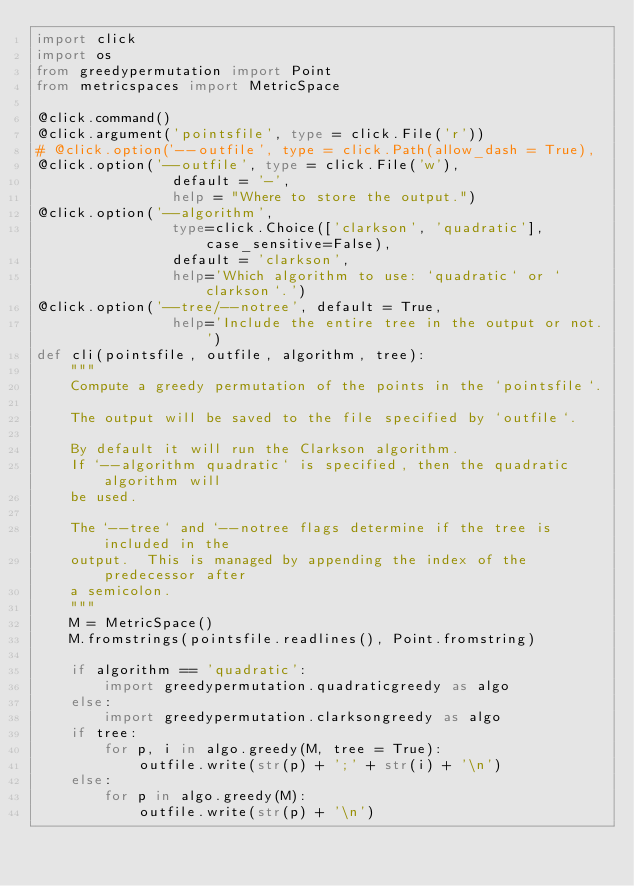<code> <loc_0><loc_0><loc_500><loc_500><_Python_>import click
import os
from greedypermutation import Point
from metricspaces import MetricSpace

@click.command()
@click.argument('pointsfile', type = click.File('r'))
# @click.option('--outfile', type = click.Path(allow_dash = True),
@click.option('--outfile', type = click.File('w'),
                default = '-',
                help = "Where to store the output.")
@click.option('--algorithm',
                type=click.Choice(['clarkson', 'quadratic'], case_sensitive=False),
                default = 'clarkson',
                help='Which algorithm to use: `quadratic` or `clarkson`.')
@click.option('--tree/--notree', default = True,
                help='Include the entire tree in the output or not.')
def cli(pointsfile, outfile, algorithm, tree):
    """
    Compute a greedy permutation of the points in the `pointsfile`.

    The output will be saved to the file specified by `outfile`.

    By default it will run the Clarkson algorithm.
    If `--algorithm quadratic` is specified, then the quadratic algorithm will
    be used.

    The `--tree` and `--notree flags determine if the tree is included in the
    output.  This is managed by appending the index of the predecessor after
    a semicolon.
    """
    M = MetricSpace()
    M.fromstrings(pointsfile.readlines(), Point.fromstring)

    if algorithm == 'quadratic':
        import greedypermutation.quadraticgreedy as algo
    else:
        import greedypermutation.clarksongreedy as algo
    if tree:
        for p, i in algo.greedy(M, tree = True):
            outfile.write(str(p) + ';' + str(i) + '\n')
    else:
        for p in algo.greedy(M):
            outfile.write(str(p) + '\n')
</code> 